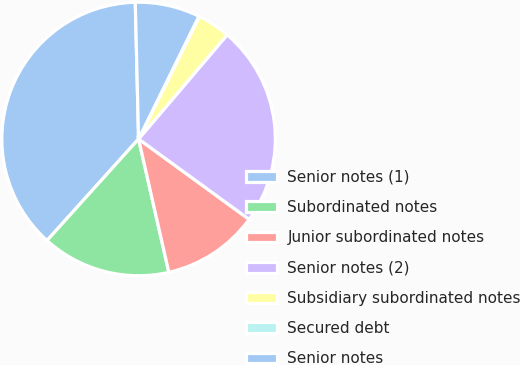Convert chart. <chart><loc_0><loc_0><loc_500><loc_500><pie_chart><fcel>Senior notes (1)<fcel>Subordinated notes<fcel>Junior subordinated notes<fcel>Senior notes (2)<fcel>Subsidiary subordinated notes<fcel>Secured debt<fcel>Senior notes<nl><fcel>37.94%<fcel>15.23%<fcel>11.44%<fcel>23.79%<fcel>3.87%<fcel>0.08%<fcel>7.65%<nl></chart> 